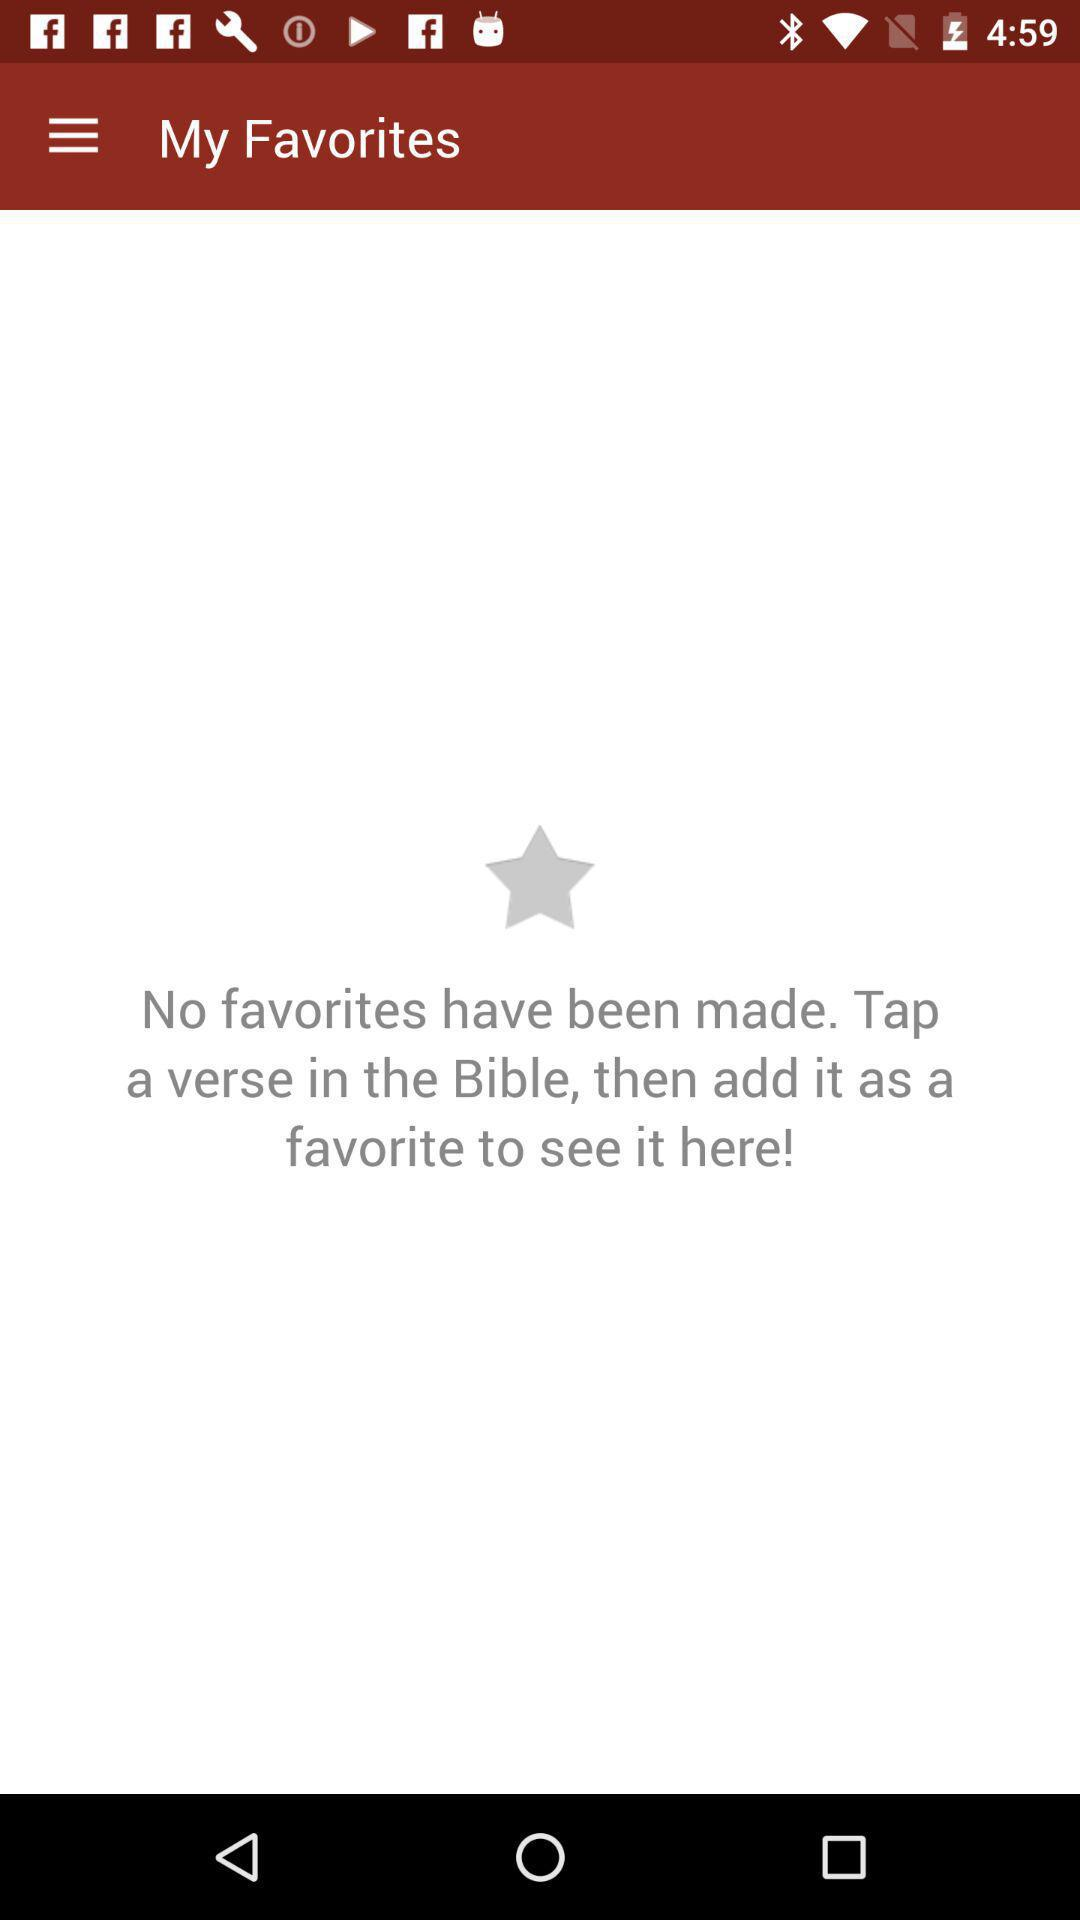What can be added to "My Favorites"? We can add "verse" to "My Favorites". 